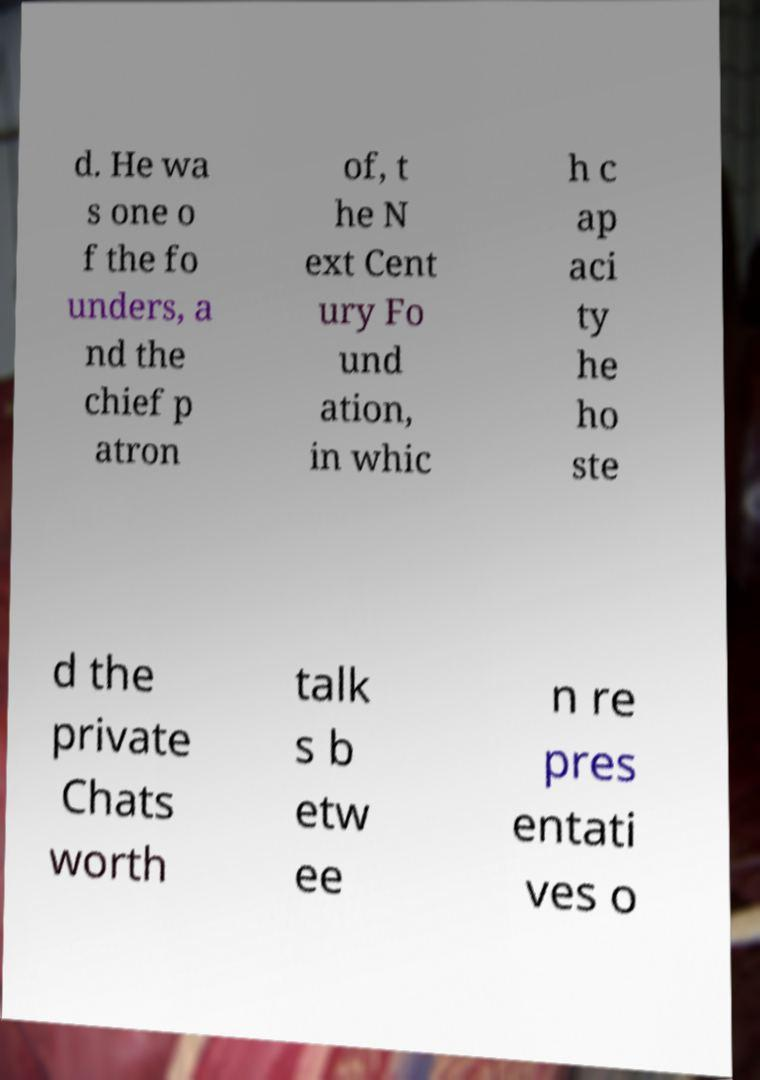I need the written content from this picture converted into text. Can you do that? d. He wa s one o f the fo unders, a nd the chief p atron of, t he N ext Cent ury Fo und ation, in whic h c ap aci ty he ho ste d the private Chats worth talk s b etw ee n re pres entati ves o 